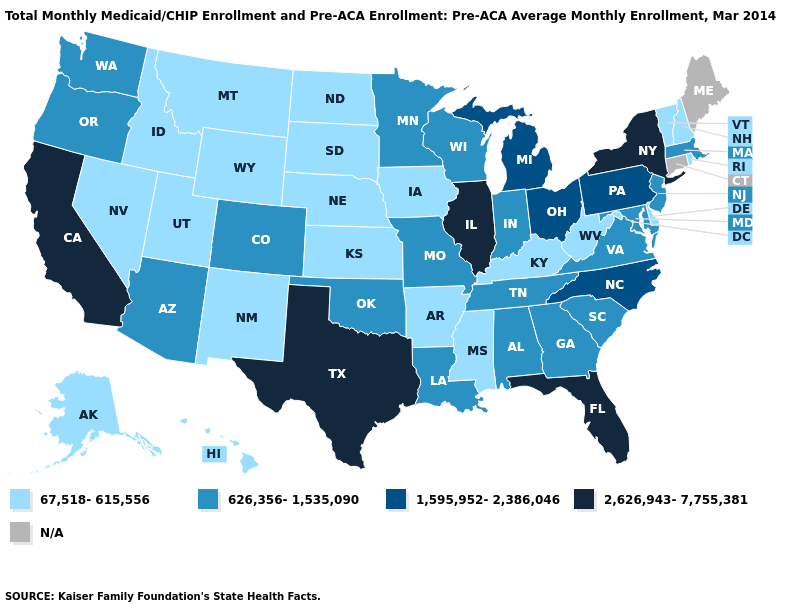Is the legend a continuous bar?
Short answer required. No. Which states have the lowest value in the USA?
Answer briefly. Alaska, Arkansas, Delaware, Hawaii, Idaho, Iowa, Kansas, Kentucky, Mississippi, Montana, Nebraska, Nevada, New Hampshire, New Mexico, North Dakota, Rhode Island, South Dakota, Utah, Vermont, West Virginia, Wyoming. Name the states that have a value in the range 2,626,943-7,755,381?
Write a very short answer. California, Florida, Illinois, New York, Texas. Does the first symbol in the legend represent the smallest category?
Answer briefly. Yes. Among the states that border Ohio , does West Virginia have the lowest value?
Be succinct. Yes. Name the states that have a value in the range 2,626,943-7,755,381?
Concise answer only. California, Florida, Illinois, New York, Texas. What is the value of Maryland?
Be succinct. 626,356-1,535,090. What is the lowest value in the West?
Answer briefly. 67,518-615,556. What is the lowest value in the USA?
Write a very short answer. 67,518-615,556. Does the first symbol in the legend represent the smallest category?
Give a very brief answer. Yes. What is the value of Hawaii?
Short answer required. 67,518-615,556. What is the lowest value in the South?
Short answer required. 67,518-615,556. What is the value of Washington?
Answer briefly. 626,356-1,535,090. Name the states that have a value in the range 67,518-615,556?
Quick response, please. Alaska, Arkansas, Delaware, Hawaii, Idaho, Iowa, Kansas, Kentucky, Mississippi, Montana, Nebraska, Nevada, New Hampshire, New Mexico, North Dakota, Rhode Island, South Dakota, Utah, Vermont, West Virginia, Wyoming. What is the value of Nebraska?
Answer briefly. 67,518-615,556. 